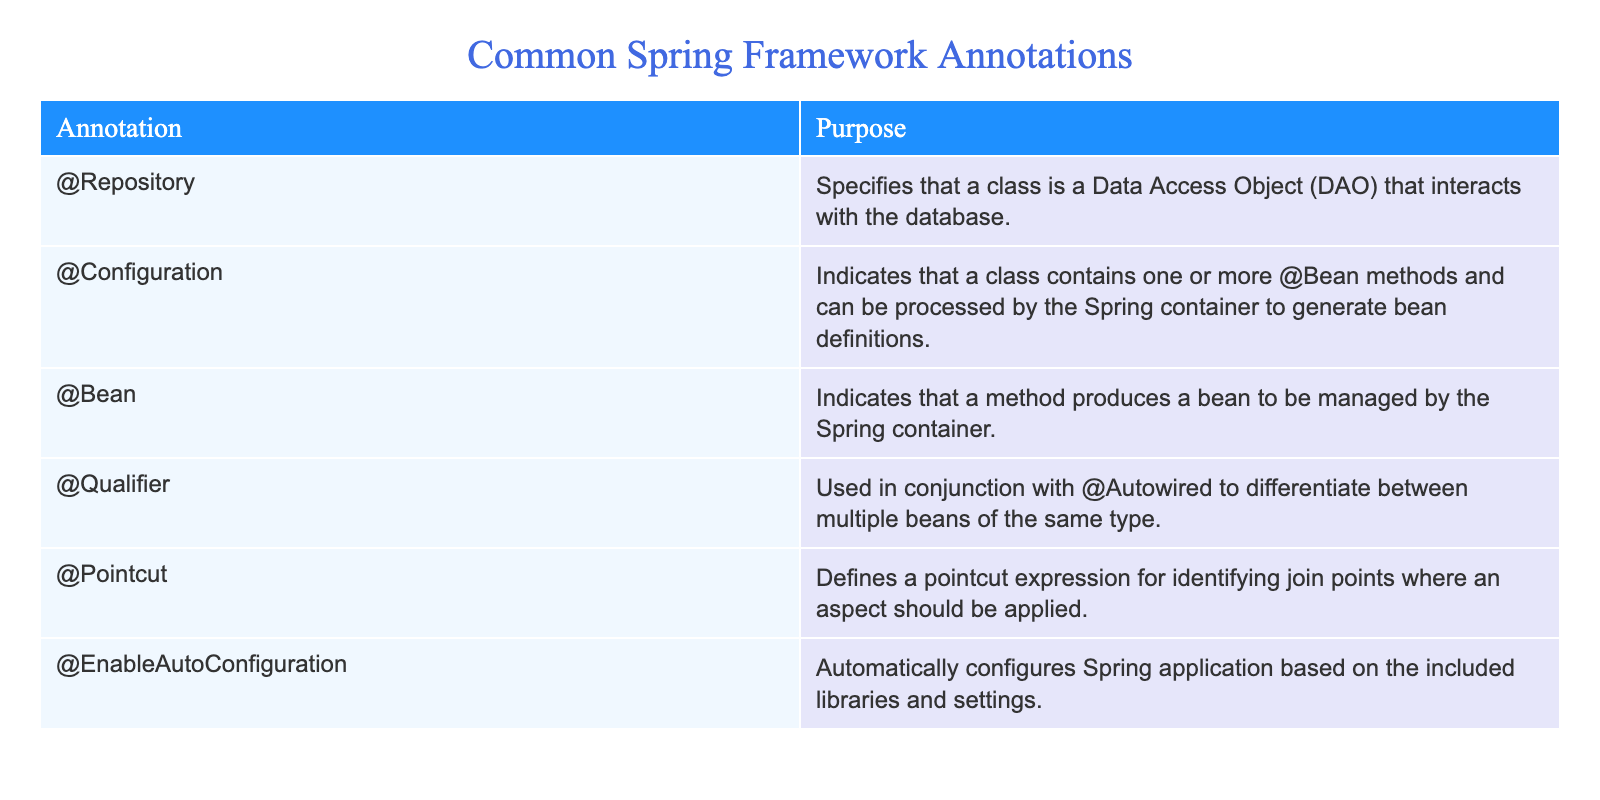What is the purpose of the @Repository annotation? The @Repository annotation is specified in the table as indicating that a class is a Data Access Object (DAO) that interacts with the database. This shows its role in the Spring Framework as a key component for database operations.
Answer: Indicates a DAO for database interaction What does the @Configuration annotation indicate? According to the table, the @Configuration annotation indicates that a class contains one or more @Bean methods. It can be processed by the Spring container to generate bean definitions, thus establishing its role in configuration management.
Answer: Indicates a class with @Bean methods for configuration How many annotations in the table relate to bean management? The table lists three annotations relevant to bean management: @Configuration, @Bean, and @Qualifier. Summing these gives three annotations associated with managing Spring beans.
Answer: Three annotations relate to bean management Is the @EnableAutoConfiguration annotation associated with configuring Spring applications? Yes, the table states that the @EnableAutoConfiguration annotation automatically configures Spring applications based on included libraries and settings. This confirms its direct association with application configuration.
Answer: Yes What are the purposes of both @Pointcut and @Qualifier annotations? The table specifies that @Pointcut defines a pointcut expression for identifying join points in aspects, while @Qualifier is used with @Autowired to differentiate multiple beans of the same type. Thus, both annotations serve distinct yet crucial roles in Spring's aspect-oriented programming and dependency injection.
Answer: @Pointcut is for defining join points; @Qualifier differentiates beans 